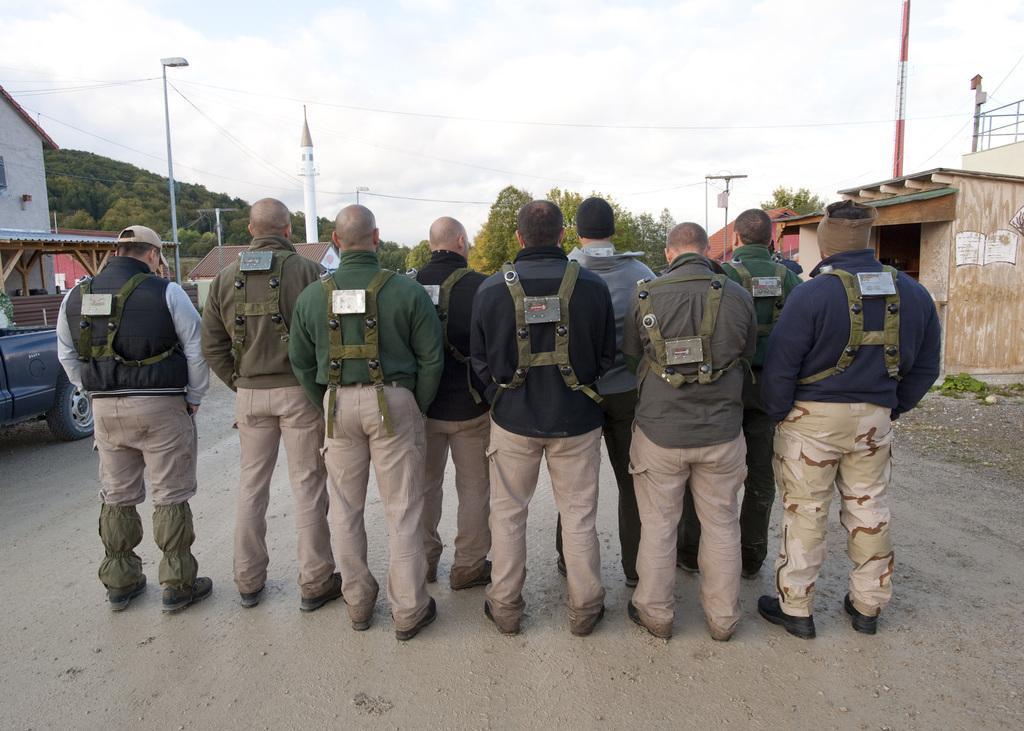Please provide a concise description of this image. In this picture there are men those who are standing in the center of the image and there are houses and trees in the background area of the image, there is a car on the left side of the image. 